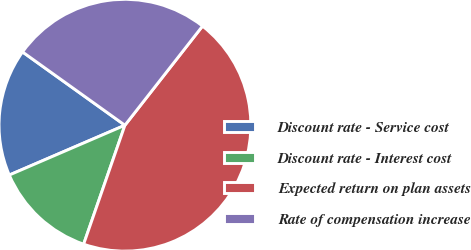Convert chart to OTSL. <chart><loc_0><loc_0><loc_500><loc_500><pie_chart><fcel>Discount rate - Service cost<fcel>Discount rate - Interest cost<fcel>Expected return on plan assets<fcel>Rate of compensation increase<nl><fcel>16.36%<fcel>13.21%<fcel>44.75%<fcel>25.68%<nl></chart> 